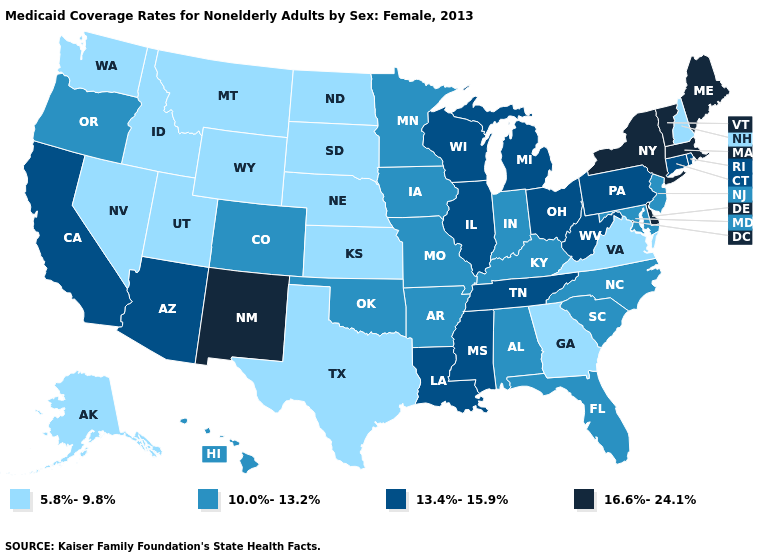Name the states that have a value in the range 10.0%-13.2%?
Write a very short answer. Alabama, Arkansas, Colorado, Florida, Hawaii, Indiana, Iowa, Kentucky, Maryland, Minnesota, Missouri, New Jersey, North Carolina, Oklahoma, Oregon, South Carolina. Name the states that have a value in the range 10.0%-13.2%?
Concise answer only. Alabama, Arkansas, Colorado, Florida, Hawaii, Indiana, Iowa, Kentucky, Maryland, Minnesota, Missouri, New Jersey, North Carolina, Oklahoma, Oregon, South Carolina. What is the value of New York?
Give a very brief answer. 16.6%-24.1%. Name the states that have a value in the range 10.0%-13.2%?
Concise answer only. Alabama, Arkansas, Colorado, Florida, Hawaii, Indiana, Iowa, Kentucky, Maryland, Minnesota, Missouri, New Jersey, North Carolina, Oklahoma, Oregon, South Carolina. Among the states that border Colorado , which have the highest value?
Give a very brief answer. New Mexico. Among the states that border Missouri , which have the lowest value?
Keep it brief. Kansas, Nebraska. Does the first symbol in the legend represent the smallest category?
Short answer required. Yes. What is the value of Delaware?
Quick response, please. 16.6%-24.1%. Does New York have the highest value in the USA?
Write a very short answer. Yes. What is the value of Virginia?
Short answer required. 5.8%-9.8%. What is the highest value in the South ?
Answer briefly. 16.6%-24.1%. What is the highest value in the MidWest ?
Answer briefly. 13.4%-15.9%. Which states have the lowest value in the South?
Keep it brief. Georgia, Texas, Virginia. 